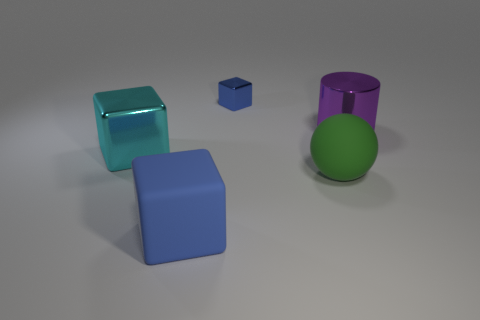What shape is the other thing that is the same color as the small shiny thing?
Your response must be concise. Cube. The matte sphere that is the same size as the cyan shiny thing is what color?
Make the answer very short. Green. Is there a large cyan cube?
Offer a very short reply. Yes. The matte object that is in front of the green sphere has what shape?
Provide a succinct answer. Cube. What number of things are on the left side of the green rubber object and right of the blue rubber thing?
Make the answer very short. 1. Are there any small yellow objects made of the same material as the big blue block?
Give a very brief answer. No. There is a thing that is the same color as the small block; what size is it?
Provide a short and direct response. Large. How many spheres are purple metallic objects or big green rubber things?
Keep it short and to the point. 1. What is the size of the purple shiny thing?
Offer a terse response. Large. There is a large green matte object; what number of cyan objects are left of it?
Give a very brief answer. 1. 